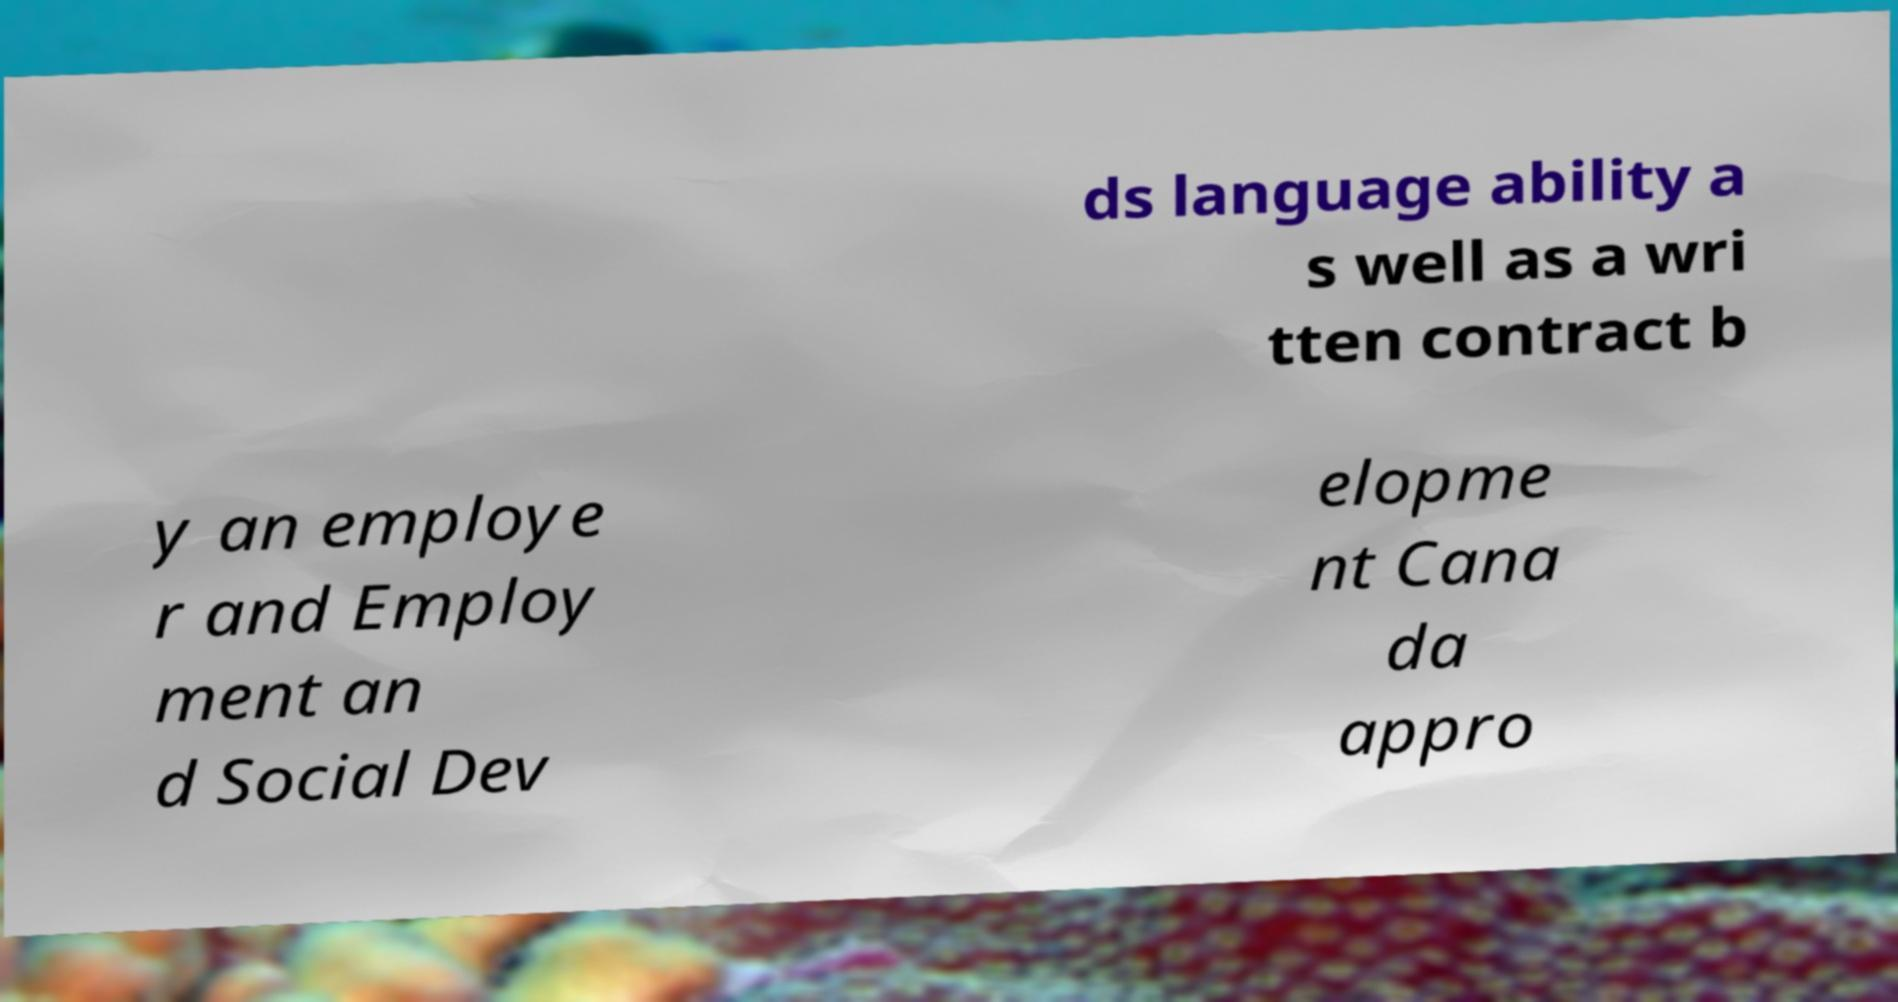Can you accurately transcribe the text from the provided image for me? ds language ability a s well as a wri tten contract b y an employe r and Employ ment an d Social Dev elopme nt Cana da appro 